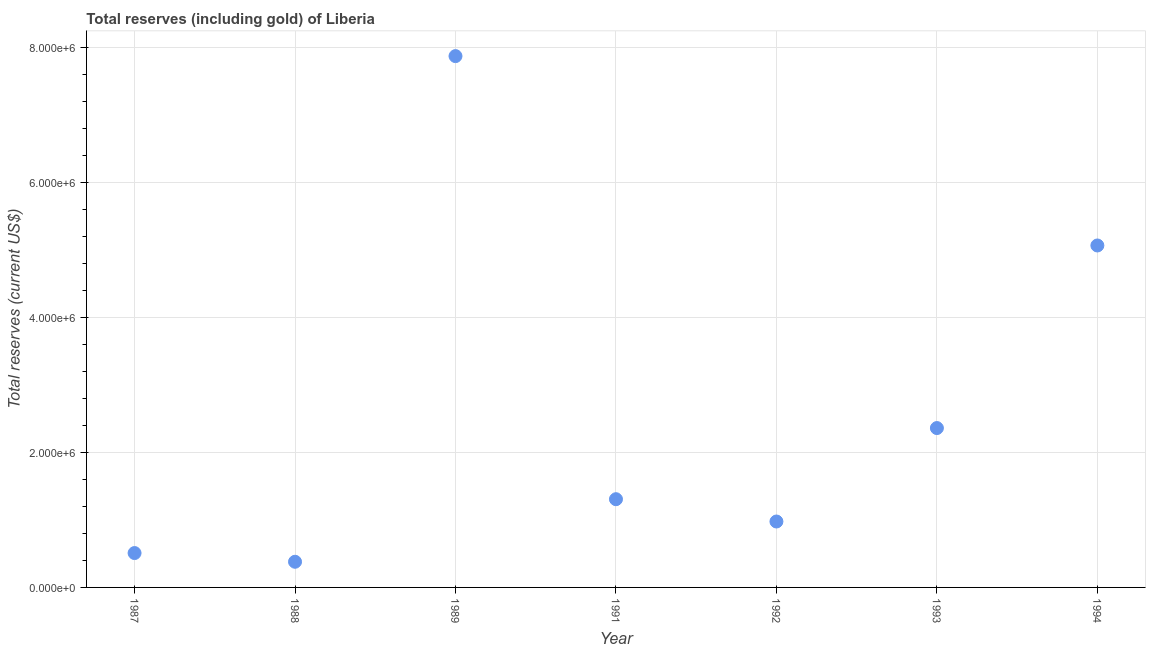What is the total reserves (including gold) in 1991?
Provide a succinct answer. 1.31e+06. Across all years, what is the maximum total reserves (including gold)?
Make the answer very short. 7.88e+06. Across all years, what is the minimum total reserves (including gold)?
Make the answer very short. 3.80e+05. What is the sum of the total reserves (including gold)?
Your response must be concise. 1.85e+07. What is the difference between the total reserves (including gold) in 1989 and 1991?
Offer a very short reply. 6.57e+06. What is the average total reserves (including gold) per year?
Ensure brevity in your answer.  2.64e+06. What is the median total reserves (including gold)?
Offer a very short reply. 1.31e+06. In how many years, is the total reserves (including gold) greater than 1600000 US$?
Keep it short and to the point. 3. Do a majority of the years between 1988 and 1994 (inclusive) have total reserves (including gold) greater than 3600000 US$?
Your answer should be compact. No. What is the ratio of the total reserves (including gold) in 1988 to that in 1994?
Ensure brevity in your answer.  0.08. Is the difference between the total reserves (including gold) in 1987 and 1993 greater than the difference between any two years?
Provide a succinct answer. No. What is the difference between the highest and the second highest total reserves (including gold)?
Your answer should be very brief. 2.81e+06. What is the difference between the highest and the lowest total reserves (including gold)?
Your response must be concise. 7.50e+06. Does the total reserves (including gold) monotonically increase over the years?
Your answer should be compact. No. How many years are there in the graph?
Your answer should be very brief. 7. What is the difference between two consecutive major ticks on the Y-axis?
Your response must be concise. 2.00e+06. Are the values on the major ticks of Y-axis written in scientific E-notation?
Your answer should be very brief. Yes. Does the graph contain any zero values?
Offer a very short reply. No. Does the graph contain grids?
Keep it short and to the point. Yes. What is the title of the graph?
Your answer should be compact. Total reserves (including gold) of Liberia. What is the label or title of the Y-axis?
Provide a succinct answer. Total reserves (current US$). What is the Total reserves (current US$) in 1987?
Provide a short and direct response. 5.10e+05. What is the Total reserves (current US$) in 1988?
Provide a succinct answer. 3.80e+05. What is the Total reserves (current US$) in 1989?
Your answer should be compact. 7.88e+06. What is the Total reserves (current US$) in 1991?
Your answer should be compact. 1.31e+06. What is the Total reserves (current US$) in 1992?
Offer a very short reply. 9.77e+05. What is the Total reserves (current US$) in 1993?
Ensure brevity in your answer.  2.36e+06. What is the Total reserves (current US$) in 1994?
Ensure brevity in your answer.  5.07e+06. What is the difference between the Total reserves (current US$) in 1987 and 1988?
Your answer should be very brief. 1.29e+05. What is the difference between the Total reserves (current US$) in 1987 and 1989?
Your answer should be compact. -7.37e+06. What is the difference between the Total reserves (current US$) in 1987 and 1991?
Your answer should be compact. -7.98e+05. What is the difference between the Total reserves (current US$) in 1987 and 1992?
Your answer should be compact. -4.68e+05. What is the difference between the Total reserves (current US$) in 1987 and 1993?
Your answer should be compact. -1.85e+06. What is the difference between the Total reserves (current US$) in 1987 and 1994?
Your response must be concise. -4.56e+06. What is the difference between the Total reserves (current US$) in 1988 and 1989?
Offer a terse response. -7.50e+06. What is the difference between the Total reserves (current US$) in 1988 and 1991?
Provide a short and direct response. -9.28e+05. What is the difference between the Total reserves (current US$) in 1988 and 1992?
Provide a short and direct response. -5.97e+05. What is the difference between the Total reserves (current US$) in 1988 and 1993?
Offer a very short reply. -1.98e+06. What is the difference between the Total reserves (current US$) in 1988 and 1994?
Your response must be concise. -4.69e+06. What is the difference between the Total reserves (current US$) in 1989 and 1991?
Your response must be concise. 6.57e+06. What is the difference between the Total reserves (current US$) in 1989 and 1992?
Your answer should be compact. 6.90e+06. What is the difference between the Total reserves (current US$) in 1989 and 1993?
Give a very brief answer. 5.51e+06. What is the difference between the Total reserves (current US$) in 1989 and 1994?
Your answer should be compact. 2.81e+06. What is the difference between the Total reserves (current US$) in 1991 and 1992?
Keep it short and to the point. 3.31e+05. What is the difference between the Total reserves (current US$) in 1991 and 1993?
Keep it short and to the point. -1.05e+06. What is the difference between the Total reserves (current US$) in 1991 and 1994?
Provide a short and direct response. -3.76e+06. What is the difference between the Total reserves (current US$) in 1992 and 1993?
Offer a very short reply. -1.39e+06. What is the difference between the Total reserves (current US$) in 1992 and 1994?
Your answer should be compact. -4.09e+06. What is the difference between the Total reserves (current US$) in 1993 and 1994?
Ensure brevity in your answer.  -2.71e+06. What is the ratio of the Total reserves (current US$) in 1987 to that in 1988?
Provide a short and direct response. 1.34. What is the ratio of the Total reserves (current US$) in 1987 to that in 1989?
Provide a succinct answer. 0.07. What is the ratio of the Total reserves (current US$) in 1987 to that in 1991?
Give a very brief answer. 0.39. What is the ratio of the Total reserves (current US$) in 1987 to that in 1992?
Offer a very short reply. 0.52. What is the ratio of the Total reserves (current US$) in 1987 to that in 1993?
Provide a short and direct response. 0.22. What is the ratio of the Total reserves (current US$) in 1987 to that in 1994?
Your answer should be very brief. 0.1. What is the ratio of the Total reserves (current US$) in 1988 to that in 1989?
Keep it short and to the point. 0.05. What is the ratio of the Total reserves (current US$) in 1988 to that in 1991?
Your response must be concise. 0.29. What is the ratio of the Total reserves (current US$) in 1988 to that in 1992?
Your response must be concise. 0.39. What is the ratio of the Total reserves (current US$) in 1988 to that in 1993?
Your answer should be compact. 0.16. What is the ratio of the Total reserves (current US$) in 1988 to that in 1994?
Provide a short and direct response. 0.07. What is the ratio of the Total reserves (current US$) in 1989 to that in 1991?
Your response must be concise. 6.02. What is the ratio of the Total reserves (current US$) in 1989 to that in 1992?
Provide a succinct answer. 8.06. What is the ratio of the Total reserves (current US$) in 1989 to that in 1993?
Offer a terse response. 3.33. What is the ratio of the Total reserves (current US$) in 1989 to that in 1994?
Provide a short and direct response. 1.55. What is the ratio of the Total reserves (current US$) in 1991 to that in 1992?
Your answer should be very brief. 1.34. What is the ratio of the Total reserves (current US$) in 1991 to that in 1993?
Ensure brevity in your answer.  0.55. What is the ratio of the Total reserves (current US$) in 1991 to that in 1994?
Give a very brief answer. 0.26. What is the ratio of the Total reserves (current US$) in 1992 to that in 1993?
Provide a short and direct response. 0.41. What is the ratio of the Total reserves (current US$) in 1992 to that in 1994?
Keep it short and to the point. 0.19. What is the ratio of the Total reserves (current US$) in 1993 to that in 1994?
Offer a terse response. 0.47. 